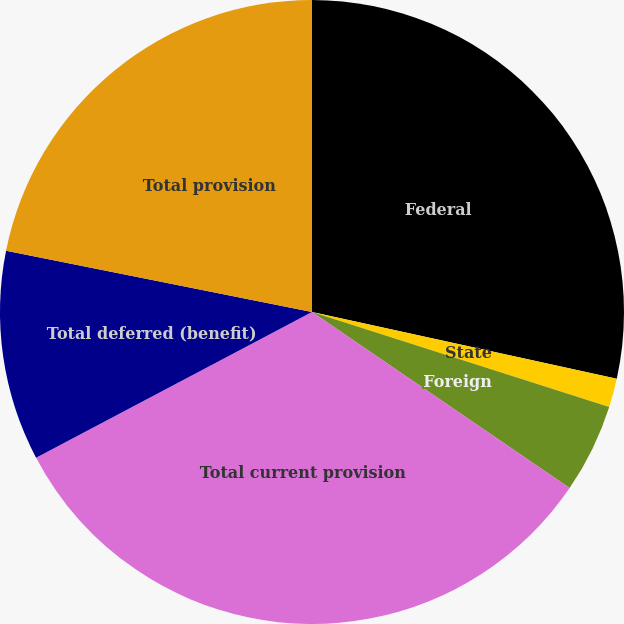<chart> <loc_0><loc_0><loc_500><loc_500><pie_chart><fcel>Federal<fcel>State<fcel>Foreign<fcel>Total current provision<fcel>Total deferred (benefit)<fcel>Total provision<nl><fcel>28.43%<fcel>1.49%<fcel>4.62%<fcel>32.73%<fcel>10.88%<fcel>21.85%<nl></chart> 